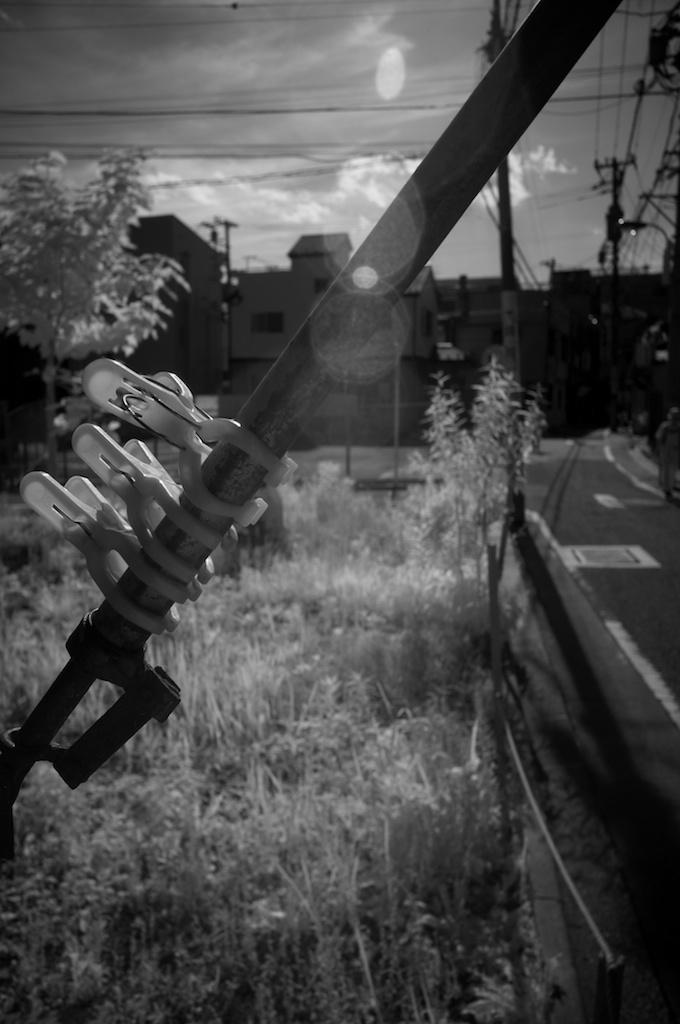What is located in the front of the image? There is a rod and clips in the front of the image. What can be seen in the background of the image? There are current polls, a tree, grass, a road, buildings, and the sky visible in the background of the image. What type of disease is depicted in the image? There is no disease depicted in the image; it features a rod, clips, and various background elements. What is the head doing in the image? There is no head present in the image. 